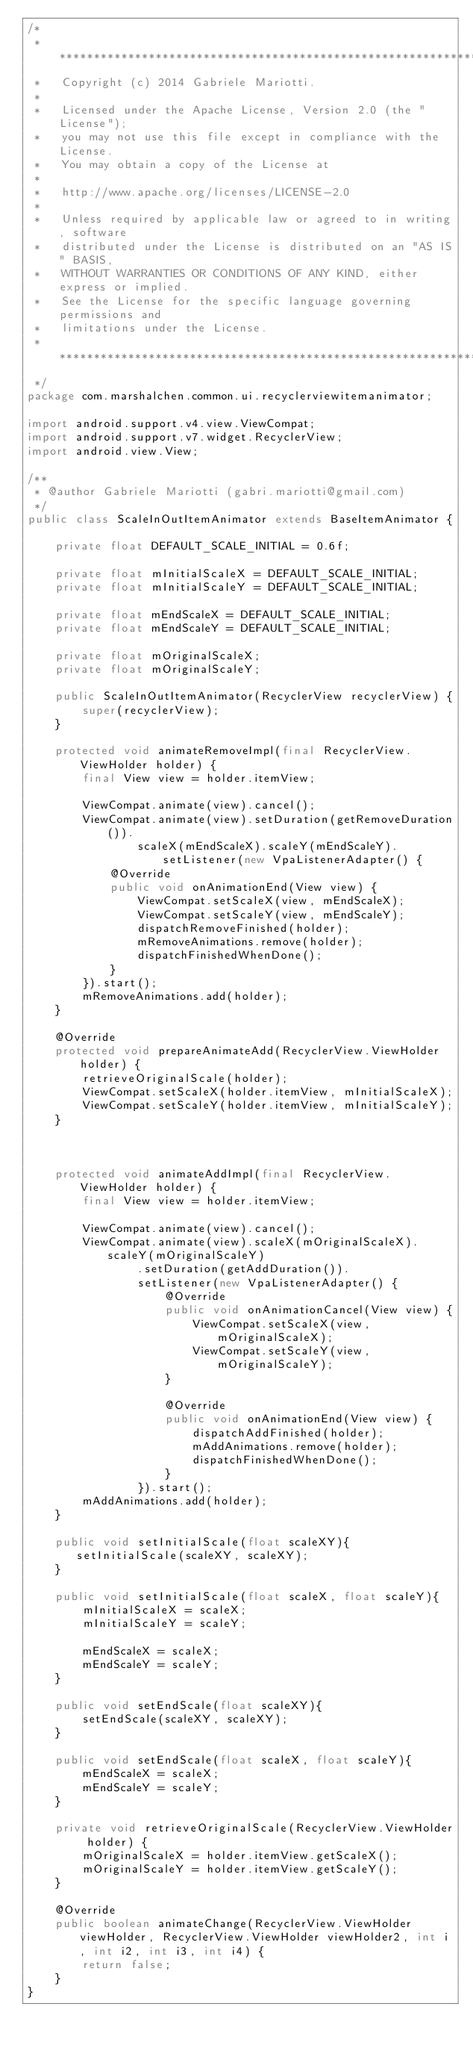Convert code to text. <code><loc_0><loc_0><loc_500><loc_500><_Java_>/*
 * ******************************************************************************
 *   Copyright (c) 2014 Gabriele Mariotti.
 *
 *   Licensed under the Apache License, Version 2.0 (the "License");
 *   you may not use this file except in compliance with the License.
 *   You may obtain a copy of the License at
 *
 *   http://www.apache.org/licenses/LICENSE-2.0
 *
 *   Unless required by applicable law or agreed to in writing, software
 *   distributed under the License is distributed on an "AS IS" BASIS,
 *   WITHOUT WARRANTIES OR CONDITIONS OF ANY KIND, either express or implied.
 *   See the License for the specific language governing permissions and
 *   limitations under the License.
 *  *****************************************************************************
 */
package com.marshalchen.common.ui.recyclerviewitemanimator;

import android.support.v4.view.ViewCompat;
import android.support.v7.widget.RecyclerView;
import android.view.View;

/**
 * @author Gabriele Mariotti (gabri.mariotti@gmail.com)
 */
public class ScaleInOutItemAnimator extends BaseItemAnimator {

    private float DEFAULT_SCALE_INITIAL = 0.6f;

    private float mInitialScaleX = DEFAULT_SCALE_INITIAL;
    private float mInitialScaleY = DEFAULT_SCALE_INITIAL;

    private float mEndScaleX = DEFAULT_SCALE_INITIAL;
    private float mEndScaleY = DEFAULT_SCALE_INITIAL;

    private float mOriginalScaleX;
    private float mOriginalScaleY;

    public ScaleInOutItemAnimator(RecyclerView recyclerView) {
        super(recyclerView);
    }

    protected void animateRemoveImpl(final RecyclerView.ViewHolder holder) {
        final View view = holder.itemView;

        ViewCompat.animate(view).cancel();
        ViewCompat.animate(view).setDuration(getRemoveDuration()).
                scaleX(mEndScaleX).scaleY(mEndScaleY).setListener(new VpaListenerAdapter() {
            @Override
            public void onAnimationEnd(View view) {
                ViewCompat.setScaleX(view, mEndScaleX);
                ViewCompat.setScaleY(view, mEndScaleY);
                dispatchRemoveFinished(holder);
                mRemoveAnimations.remove(holder);
                dispatchFinishedWhenDone();
            }
        }).start();
        mRemoveAnimations.add(holder);
    }

    @Override
    protected void prepareAnimateAdd(RecyclerView.ViewHolder holder) {
        retrieveOriginalScale(holder);
        ViewCompat.setScaleX(holder.itemView, mInitialScaleX);
        ViewCompat.setScaleY(holder.itemView, mInitialScaleY);
    }



    protected void animateAddImpl(final RecyclerView.ViewHolder holder) {
        final View view = holder.itemView;

        ViewCompat.animate(view).cancel();
        ViewCompat.animate(view).scaleX(mOriginalScaleX).scaleY(mOriginalScaleY)
                .setDuration(getAddDuration()).
                setListener(new VpaListenerAdapter() {
                    @Override
                    public void onAnimationCancel(View view) {
                        ViewCompat.setScaleX(view, mOriginalScaleX);
                        ViewCompat.setScaleY(view, mOriginalScaleY);
                    }

                    @Override
                    public void onAnimationEnd(View view) {
                        dispatchAddFinished(holder);
                        mAddAnimations.remove(holder);
                        dispatchFinishedWhenDone();
                    }
                }).start();
        mAddAnimations.add(holder);
    }

    public void setInitialScale(float scaleXY){
       setInitialScale(scaleXY, scaleXY);
    }

    public void setInitialScale(float scaleX, float scaleY){
        mInitialScaleX = scaleX;
        mInitialScaleY = scaleY;

        mEndScaleX = scaleX;
        mEndScaleY = scaleY;
    }

    public void setEndScale(float scaleXY){
        setEndScale(scaleXY, scaleXY);
    }

    public void setEndScale(float scaleX, float scaleY){
        mEndScaleX = scaleX;
        mEndScaleY = scaleY;
    }

    private void retrieveOriginalScale(RecyclerView.ViewHolder holder) {
        mOriginalScaleX = holder.itemView.getScaleX();
        mOriginalScaleY = holder.itemView.getScaleY();
    }

    @Override
    public boolean animateChange(RecyclerView.ViewHolder viewHolder, RecyclerView.ViewHolder viewHolder2, int i, int i2, int i3, int i4) {
        return false;
    }
}
</code> 